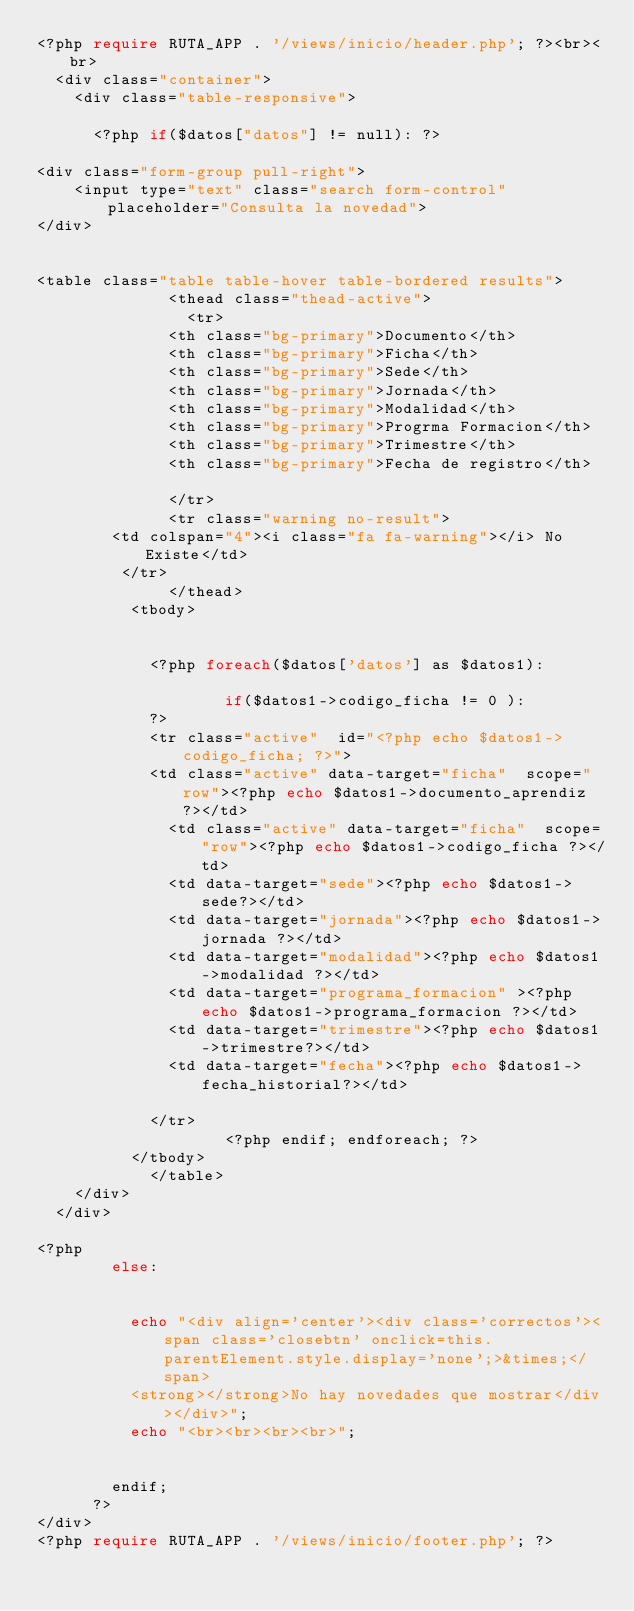<code> <loc_0><loc_0><loc_500><loc_500><_PHP_><?php require RUTA_APP . '/views/inicio/header.php'; ?><br><br>
  <div class="container">
    <div class="table-responsive">

      <?php if($datos["datos"] != null): ?>

<div class="form-group pull-right">
    <input type="text" class="search form-control" placeholder="Consulta la novedad">
</div>


<table class="table table-hover table-bordered results">
    		  <thead class="thead-active">
    		    <tr>
              <th class="bg-primary">Documento</th>
              <th class="bg-primary">Ficha</th>
              <th class="bg-primary">Sede</th>
              <th class="bg-primary">Jornada</th>
              <th class="bg-primary">Modalidad</th>
              <th class="bg-primary">Progrma Formacion</th>
              <th class="bg-primary">Trimestre</th>
              <th class="bg-primary">Fecha de registro</th>

              </tr>
              <tr class="warning no-result">
        <td colspan="4"><i class="fa fa-warning"></i> No Existe</td>
         </tr>
    		  </thead>
          <tbody>
          

            <?php foreach($datos['datos'] as $datos1):

                    if($datos1->codigo_ficha != 0 ):
            ?>
            <tr class="active"  id="<?php echo $datos1->codigo_ficha; ?>">
            <td class="active" data-target="ficha"  scope="row"><?php echo $datos1->documento_aprendiz ?></td>
              <td class="active" data-target="ficha"  scope="row"><?php echo $datos1->codigo_ficha ?></td>
              <td data-target="sede"><?php echo $datos1->sede?></td>
              <td data-target="jornada"><?php echo $datos1->jornada ?></td>
              <td data-target="modalidad"><?php echo $datos1->modalidad ?></td>
              <td data-target="programa_formacion" ><?php echo $datos1->programa_formacion ?></td>
              <td data-target="trimestre"><?php echo $datos1->trimestre?></td>
              <td data-target="fecha"><?php echo $datos1->fecha_historial?></td>

            </tr>
                    <?php endif; endforeach; ?>
          </tbody>
    		</table>
  	</div>
  </div>  
 
<?php   
        else:


          echo "<div align='center'><div class='correctos'><span class='closebtn' onclick=this.parentElement.style.display='none';>&times;</span> 
          <strong></strong>No hay novedades que mostrar</div></div>";
          echo "<br><br><br><br>";


        endif; 
      ?>
</div>
<?php require RUTA_APP . '/views/inicio/footer.php'; ?>
</code> 